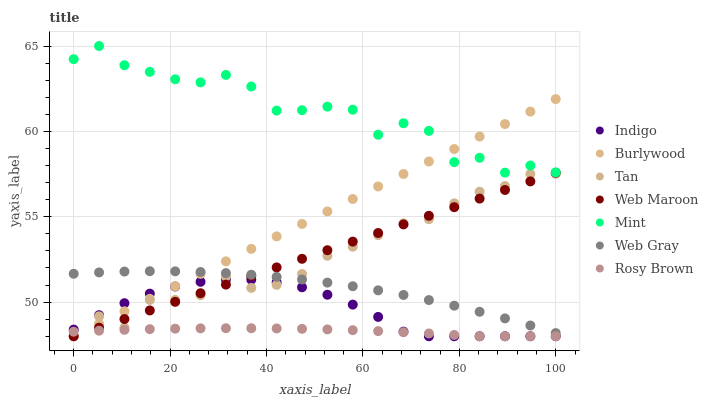Does Rosy Brown have the minimum area under the curve?
Answer yes or no. Yes. Does Mint have the maximum area under the curve?
Answer yes or no. Yes. Does Indigo have the minimum area under the curve?
Answer yes or no. No. Does Indigo have the maximum area under the curve?
Answer yes or no. No. Is Web Maroon the smoothest?
Answer yes or no. Yes. Is Mint the roughest?
Answer yes or no. Yes. Is Indigo the smoothest?
Answer yes or no. No. Is Indigo the roughest?
Answer yes or no. No. Does Indigo have the lowest value?
Answer yes or no. Yes. Does Mint have the lowest value?
Answer yes or no. No. Does Mint have the highest value?
Answer yes or no. Yes. Does Indigo have the highest value?
Answer yes or no. No. Is Rosy Brown less than Web Gray?
Answer yes or no. Yes. Is Mint greater than Indigo?
Answer yes or no. Yes. Does Web Maroon intersect Rosy Brown?
Answer yes or no. Yes. Is Web Maroon less than Rosy Brown?
Answer yes or no. No. Is Web Maroon greater than Rosy Brown?
Answer yes or no. No. Does Rosy Brown intersect Web Gray?
Answer yes or no. No. 